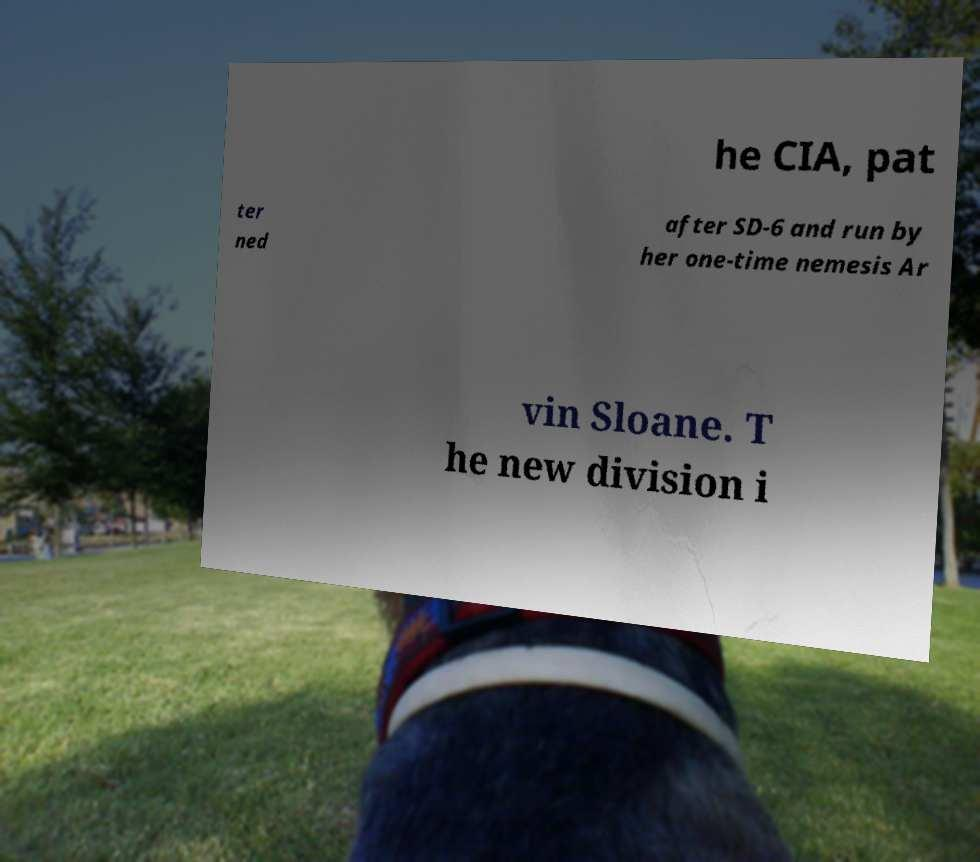Could you extract and type out the text from this image? he CIA, pat ter ned after SD-6 and run by her one-time nemesis Ar vin Sloane. T he new division i 